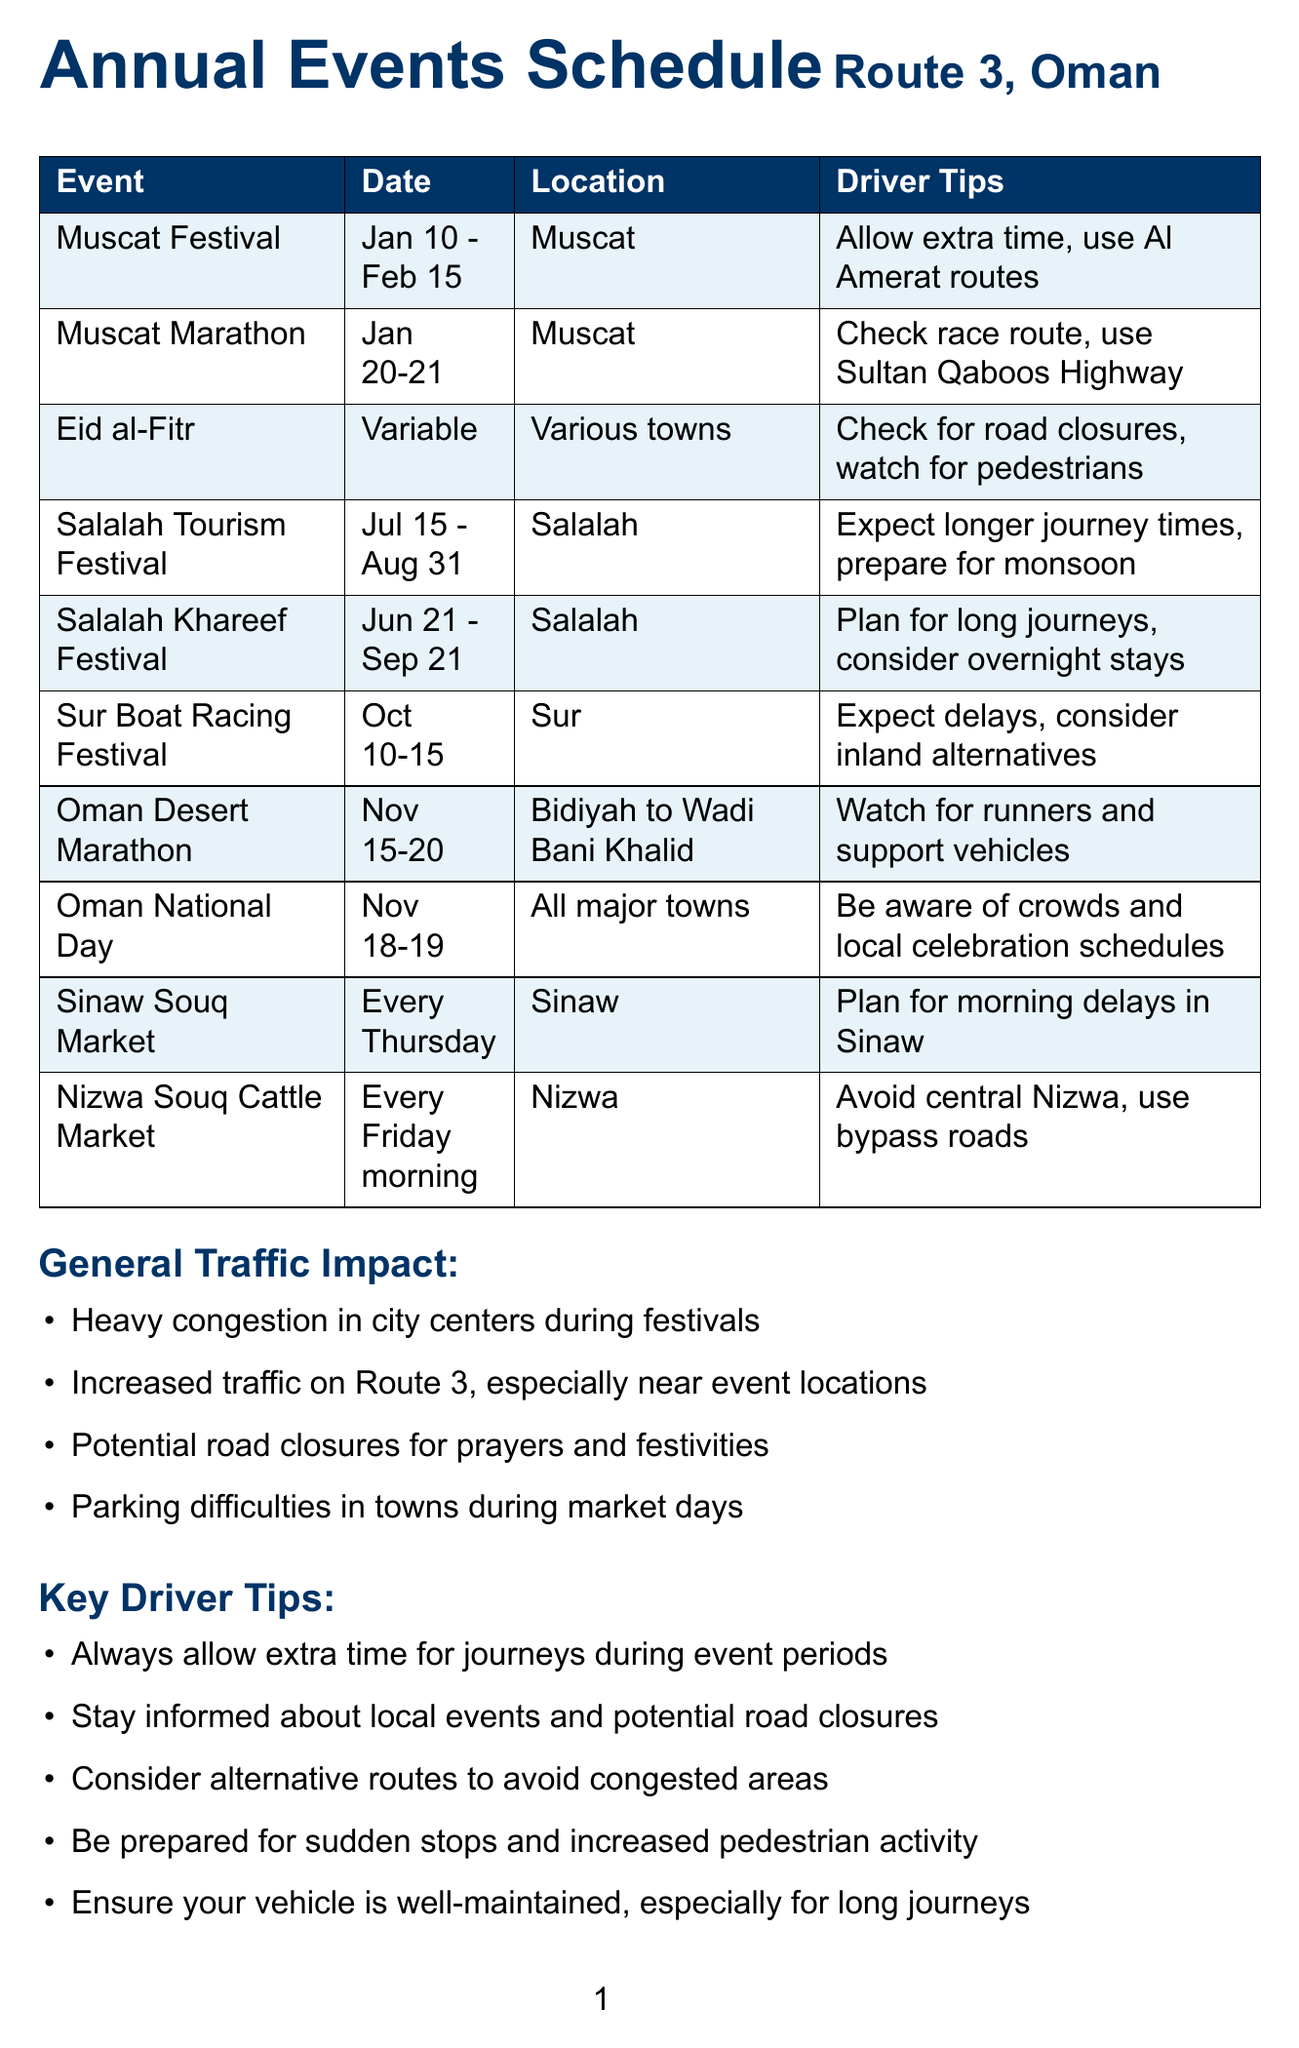What is the location of the Muscat Festival? The Muscat Festival is located in Muscat, which is the start of Route 3.
Answer: Muscat (Start of Route 3) What dates does the Salalah Tourism Festival occur? The Salalah Tourism Festival takes place from July 15 to August 31.
Answer: July 15 - August 31 What is the traffic impact during Eid al-Fitr celebrations? The Eid al-Fitr celebrations lead to increased local traffic in towns and potential road closures.
Answer: Increased local traffic; potential road closures On which day does the Sinaw Souq Market take place? The Sinaw Souq Market occurs every Thursday.
Answer: Every Thursday How long does the Sur Boat Racing Festival last? The Sur Boat Racing Festival lasts for six days from October 10 to October 15.
Answer: October 10-15 What should drivers do during the Salalah Khareef Festival? Drivers should plan for significantly longer journey times and consider overnight stays.
Answer: Plan for significantly longer journey times What is a common driver tip for attending events? Drivers are advised to allow extra time for journeys during event periods.
Answer: Allow extra time for journeys Which major event causes road closures along the Corniche in Muscat? The Muscat Marathon causes road closures in parts of Muscat, particularly along the Corniche.
Answer: Muscat Marathon What type of events cause increased traffic along Route 3? Festivals and celebrations, especially those held in major towns, cause increased traffic along Route 3.
Answer: Festivals and celebrations 